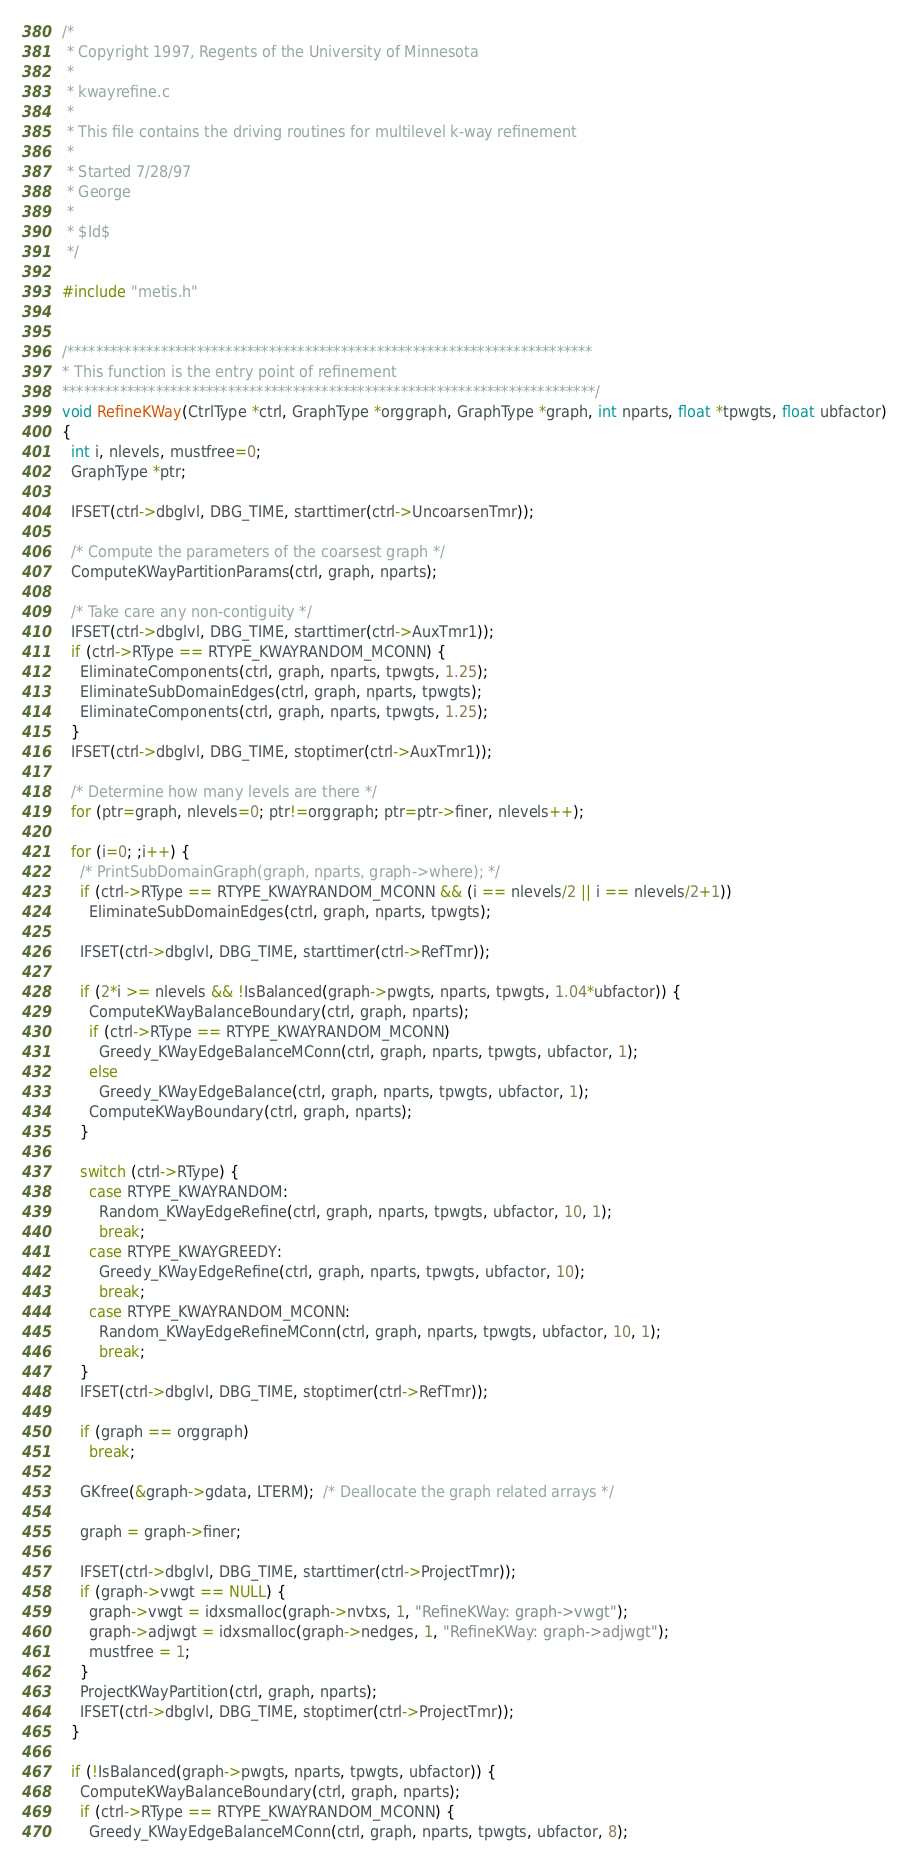<code> <loc_0><loc_0><loc_500><loc_500><_C_>/*
 * Copyright 1997, Regents of the University of Minnesota
 *
 * kwayrefine.c
 *
 * This file contains the driving routines for multilevel k-way refinement
 *
 * Started 7/28/97
 * George
 *
 * $Id$
 */

#include "metis.h"


/*************************************************************************
* This function is the entry point of refinement
**************************************************************************/
void RefineKWay(CtrlType *ctrl, GraphType *orggraph, GraphType *graph, int nparts, float *tpwgts, float ubfactor)
{
  int i, nlevels, mustfree=0;
  GraphType *ptr;

  IFSET(ctrl->dbglvl, DBG_TIME, starttimer(ctrl->UncoarsenTmr));

  /* Compute the parameters of the coarsest graph */
  ComputeKWayPartitionParams(ctrl, graph, nparts);

  /* Take care any non-contiguity */
  IFSET(ctrl->dbglvl, DBG_TIME, starttimer(ctrl->AuxTmr1));
  if (ctrl->RType == RTYPE_KWAYRANDOM_MCONN) {
    EliminateComponents(ctrl, graph, nparts, tpwgts, 1.25);
    EliminateSubDomainEdges(ctrl, graph, nparts, tpwgts);
    EliminateComponents(ctrl, graph, nparts, tpwgts, 1.25);
  }
  IFSET(ctrl->dbglvl, DBG_TIME, stoptimer(ctrl->AuxTmr1));

  /* Determine how many levels are there */
  for (ptr=graph, nlevels=0; ptr!=orggraph; ptr=ptr->finer, nlevels++); 

  for (i=0; ;i++) {
    /* PrintSubDomainGraph(graph, nparts, graph->where); */
    if (ctrl->RType == RTYPE_KWAYRANDOM_MCONN && (i == nlevels/2 || i == nlevels/2+1))
      EliminateSubDomainEdges(ctrl, graph, nparts, tpwgts);

    IFSET(ctrl->dbglvl, DBG_TIME, starttimer(ctrl->RefTmr));

    if (2*i >= nlevels && !IsBalanced(graph->pwgts, nparts, tpwgts, 1.04*ubfactor)) {
      ComputeKWayBalanceBoundary(ctrl, graph, nparts);
      if (ctrl->RType == RTYPE_KWAYRANDOM_MCONN)
        Greedy_KWayEdgeBalanceMConn(ctrl, graph, nparts, tpwgts, ubfactor, 1); 
      else
        Greedy_KWayEdgeBalance(ctrl, graph, nparts, tpwgts, ubfactor, 1); 
      ComputeKWayBoundary(ctrl, graph, nparts);
    }

    switch (ctrl->RType) {
      case RTYPE_KWAYRANDOM:
        Random_KWayEdgeRefine(ctrl, graph, nparts, tpwgts, ubfactor, 10, 1); 
        break;
      case RTYPE_KWAYGREEDY:
        Greedy_KWayEdgeRefine(ctrl, graph, nparts, tpwgts, ubfactor, 10); 
        break;
      case RTYPE_KWAYRANDOM_MCONN:
        Random_KWayEdgeRefineMConn(ctrl, graph, nparts, tpwgts, ubfactor, 10, 1); 
        break;
    }
    IFSET(ctrl->dbglvl, DBG_TIME, stoptimer(ctrl->RefTmr));

    if (graph == orggraph)
      break;

    GKfree(&graph->gdata, LTERM);  /* Deallocate the graph related arrays */

    graph = graph->finer;

    IFSET(ctrl->dbglvl, DBG_TIME, starttimer(ctrl->ProjectTmr));
    if (graph->vwgt == NULL) {
      graph->vwgt = idxsmalloc(graph->nvtxs, 1, "RefineKWay: graph->vwgt");
      graph->adjwgt = idxsmalloc(graph->nedges, 1, "RefineKWay: graph->adjwgt");
      mustfree = 1;
    }
    ProjectKWayPartition(ctrl, graph, nparts);
    IFSET(ctrl->dbglvl, DBG_TIME, stoptimer(ctrl->ProjectTmr));
  }

  if (!IsBalanced(graph->pwgts, nparts, tpwgts, ubfactor)) {
    ComputeKWayBalanceBoundary(ctrl, graph, nparts);
    if (ctrl->RType == RTYPE_KWAYRANDOM_MCONN) {
      Greedy_KWayEdgeBalanceMConn(ctrl, graph, nparts, tpwgts, ubfactor, 8); </code> 